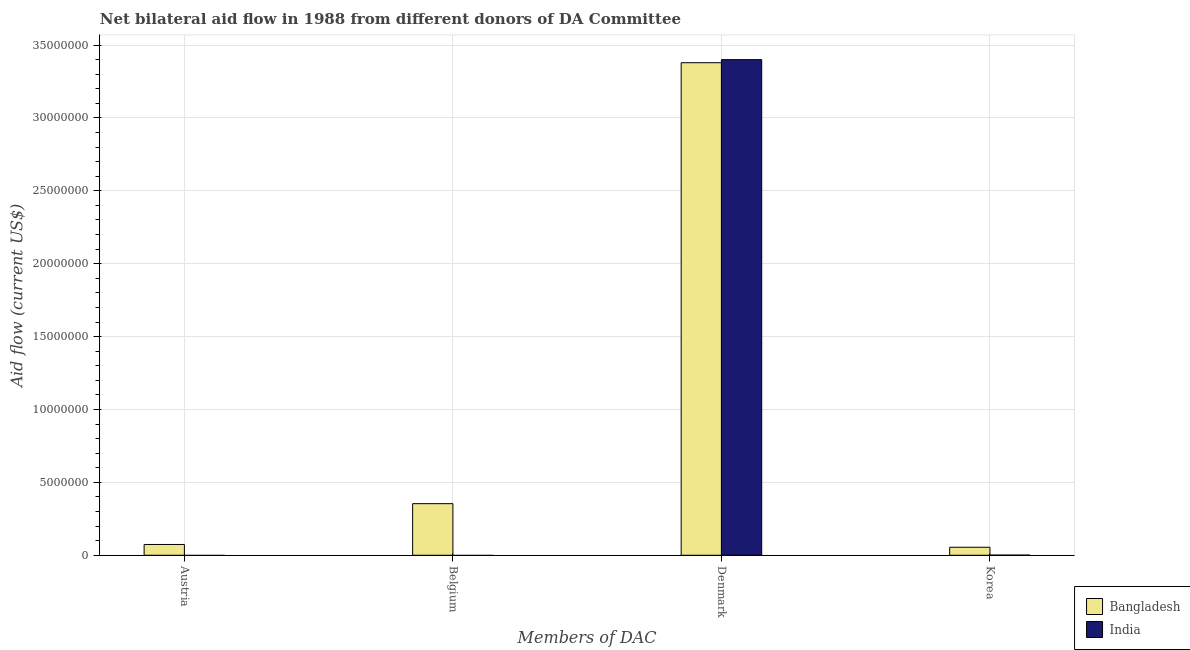Are the number of bars per tick equal to the number of legend labels?
Provide a succinct answer. No. How many bars are there on the 4th tick from the right?
Offer a terse response. 1. What is the label of the 1st group of bars from the left?
Keep it short and to the point. Austria. What is the amount of aid given by denmark in India?
Offer a terse response. 3.40e+07. Across all countries, what is the maximum amount of aid given by austria?
Make the answer very short. 7.40e+05. Across all countries, what is the minimum amount of aid given by denmark?
Give a very brief answer. 3.38e+07. In which country was the amount of aid given by denmark maximum?
Your answer should be compact. India. What is the total amount of aid given by korea in the graph?
Provide a succinct answer. 5.60e+05. What is the difference between the amount of aid given by denmark in Bangladesh and that in India?
Ensure brevity in your answer.  -2.10e+05. What is the difference between the amount of aid given by austria in Bangladesh and the amount of aid given by denmark in India?
Ensure brevity in your answer.  -3.33e+07. What is the average amount of aid given by belgium per country?
Keep it short and to the point. 1.77e+06. What is the difference between the amount of aid given by korea and amount of aid given by austria in Bangladesh?
Provide a succinct answer. -1.90e+05. In how many countries, is the amount of aid given by belgium greater than 9000000 US$?
Ensure brevity in your answer.  0. What is the ratio of the amount of aid given by denmark in India to that in Bangladesh?
Provide a short and direct response. 1.01. Is the amount of aid given by korea in India less than that in Bangladesh?
Your response must be concise. Yes. Is the difference between the amount of aid given by korea in India and Bangladesh greater than the difference between the amount of aid given by denmark in India and Bangladesh?
Ensure brevity in your answer.  No. What is the difference between the highest and the lowest amount of aid given by korea?
Your answer should be very brief. 5.40e+05. In how many countries, is the amount of aid given by denmark greater than the average amount of aid given by denmark taken over all countries?
Give a very brief answer. 1. Is the sum of the amount of aid given by korea in Bangladesh and India greater than the maximum amount of aid given by belgium across all countries?
Ensure brevity in your answer.  No. Is it the case that in every country, the sum of the amount of aid given by belgium and amount of aid given by denmark is greater than the sum of amount of aid given by austria and amount of aid given by korea?
Provide a short and direct response. No. How many bars are there?
Your answer should be compact. 6. What is the difference between two consecutive major ticks on the Y-axis?
Your answer should be very brief. 5.00e+06. Are the values on the major ticks of Y-axis written in scientific E-notation?
Provide a short and direct response. No. How many legend labels are there?
Keep it short and to the point. 2. How are the legend labels stacked?
Make the answer very short. Vertical. What is the title of the graph?
Your answer should be very brief. Net bilateral aid flow in 1988 from different donors of DA Committee. Does "Bahrain" appear as one of the legend labels in the graph?
Your answer should be compact. No. What is the label or title of the X-axis?
Make the answer very short. Members of DAC. What is the label or title of the Y-axis?
Keep it short and to the point. Aid flow (current US$). What is the Aid flow (current US$) of Bangladesh in Austria?
Give a very brief answer. 7.40e+05. What is the Aid flow (current US$) in India in Austria?
Your answer should be very brief. 0. What is the Aid flow (current US$) of Bangladesh in Belgium?
Offer a terse response. 3.54e+06. What is the Aid flow (current US$) of India in Belgium?
Offer a very short reply. 0. What is the Aid flow (current US$) in Bangladesh in Denmark?
Make the answer very short. 3.38e+07. What is the Aid flow (current US$) in India in Denmark?
Give a very brief answer. 3.40e+07. What is the Aid flow (current US$) of India in Korea?
Offer a very short reply. 10000. Across all Members of DAC, what is the maximum Aid flow (current US$) in Bangladesh?
Keep it short and to the point. 3.38e+07. Across all Members of DAC, what is the maximum Aid flow (current US$) in India?
Your answer should be very brief. 3.40e+07. Across all Members of DAC, what is the minimum Aid flow (current US$) of India?
Your response must be concise. 0. What is the total Aid flow (current US$) of Bangladesh in the graph?
Provide a short and direct response. 3.86e+07. What is the total Aid flow (current US$) in India in the graph?
Your answer should be very brief. 3.40e+07. What is the difference between the Aid flow (current US$) in Bangladesh in Austria and that in Belgium?
Give a very brief answer. -2.80e+06. What is the difference between the Aid flow (current US$) in Bangladesh in Austria and that in Denmark?
Your answer should be very brief. -3.30e+07. What is the difference between the Aid flow (current US$) of Bangladesh in Austria and that in Korea?
Ensure brevity in your answer.  1.90e+05. What is the difference between the Aid flow (current US$) of Bangladesh in Belgium and that in Denmark?
Your response must be concise. -3.02e+07. What is the difference between the Aid flow (current US$) of Bangladesh in Belgium and that in Korea?
Give a very brief answer. 2.99e+06. What is the difference between the Aid flow (current US$) in Bangladesh in Denmark and that in Korea?
Provide a short and direct response. 3.32e+07. What is the difference between the Aid flow (current US$) of India in Denmark and that in Korea?
Give a very brief answer. 3.40e+07. What is the difference between the Aid flow (current US$) of Bangladesh in Austria and the Aid flow (current US$) of India in Denmark?
Your response must be concise. -3.33e+07. What is the difference between the Aid flow (current US$) of Bangladesh in Austria and the Aid flow (current US$) of India in Korea?
Keep it short and to the point. 7.30e+05. What is the difference between the Aid flow (current US$) of Bangladesh in Belgium and the Aid flow (current US$) of India in Denmark?
Your answer should be compact. -3.05e+07. What is the difference between the Aid flow (current US$) of Bangladesh in Belgium and the Aid flow (current US$) of India in Korea?
Ensure brevity in your answer.  3.53e+06. What is the difference between the Aid flow (current US$) in Bangladesh in Denmark and the Aid flow (current US$) in India in Korea?
Offer a very short reply. 3.38e+07. What is the average Aid flow (current US$) in Bangladesh per Members of DAC?
Keep it short and to the point. 9.66e+06. What is the average Aid flow (current US$) of India per Members of DAC?
Make the answer very short. 8.50e+06. What is the difference between the Aid flow (current US$) in Bangladesh and Aid flow (current US$) in India in Korea?
Ensure brevity in your answer.  5.40e+05. What is the ratio of the Aid flow (current US$) in Bangladesh in Austria to that in Belgium?
Offer a terse response. 0.21. What is the ratio of the Aid flow (current US$) in Bangladesh in Austria to that in Denmark?
Provide a succinct answer. 0.02. What is the ratio of the Aid flow (current US$) of Bangladesh in Austria to that in Korea?
Offer a very short reply. 1.35. What is the ratio of the Aid flow (current US$) of Bangladesh in Belgium to that in Denmark?
Give a very brief answer. 0.1. What is the ratio of the Aid flow (current US$) in Bangladesh in Belgium to that in Korea?
Keep it short and to the point. 6.44. What is the ratio of the Aid flow (current US$) in Bangladesh in Denmark to that in Korea?
Your response must be concise. 61.44. What is the ratio of the Aid flow (current US$) in India in Denmark to that in Korea?
Your response must be concise. 3400. What is the difference between the highest and the second highest Aid flow (current US$) in Bangladesh?
Your answer should be very brief. 3.02e+07. What is the difference between the highest and the lowest Aid flow (current US$) of Bangladesh?
Keep it short and to the point. 3.32e+07. What is the difference between the highest and the lowest Aid flow (current US$) in India?
Your answer should be very brief. 3.40e+07. 